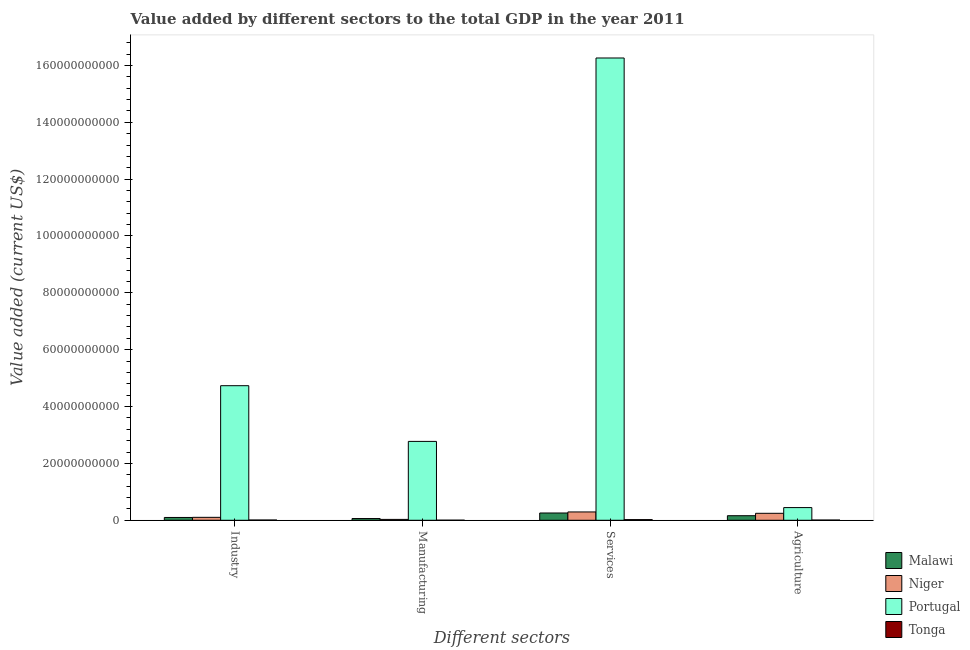Are the number of bars per tick equal to the number of legend labels?
Your answer should be very brief. Yes. How many bars are there on the 3rd tick from the left?
Your answer should be compact. 4. How many bars are there on the 1st tick from the right?
Provide a short and direct response. 4. What is the label of the 2nd group of bars from the left?
Provide a short and direct response. Manufacturing. What is the value added by services sector in Malawi?
Offer a very short reply. 2.56e+09. Across all countries, what is the maximum value added by agricultural sector?
Your answer should be very brief. 4.46e+09. Across all countries, what is the minimum value added by services sector?
Provide a short and direct response. 2.27e+08. In which country was the value added by industrial sector maximum?
Your response must be concise. Portugal. In which country was the value added by services sector minimum?
Offer a terse response. Tonga. What is the total value added by industrial sector in the graph?
Provide a succinct answer. 4.94e+1. What is the difference between the value added by manufacturing sector in Tonga and that in Malawi?
Offer a terse response. -5.83e+08. What is the difference between the value added by services sector in Niger and the value added by industrial sector in Portugal?
Keep it short and to the point. -4.44e+1. What is the average value added by agricultural sector per country?
Your answer should be very brief. 2.15e+09. What is the difference between the value added by manufacturing sector and value added by agricultural sector in Portugal?
Your answer should be very brief. 2.33e+1. What is the ratio of the value added by services sector in Tonga to that in Niger?
Your answer should be compact. 0.08. Is the value added by industrial sector in Niger less than that in Tonga?
Keep it short and to the point. No. What is the difference between the highest and the second highest value added by services sector?
Ensure brevity in your answer.  1.60e+11. What is the difference between the highest and the lowest value added by industrial sector?
Ensure brevity in your answer.  4.72e+1. In how many countries, is the value added by agricultural sector greater than the average value added by agricultural sector taken over all countries?
Your answer should be very brief. 2. What does the 2nd bar from the left in Manufacturing represents?
Keep it short and to the point. Niger. What does the 1st bar from the right in Services represents?
Give a very brief answer. Tonga. How many countries are there in the graph?
Make the answer very short. 4. What is the difference between two consecutive major ticks on the Y-axis?
Your answer should be compact. 2.00e+1. Are the values on the major ticks of Y-axis written in scientific E-notation?
Your answer should be compact. No. Does the graph contain any zero values?
Offer a very short reply. No. Does the graph contain grids?
Offer a very short reply. No. Where does the legend appear in the graph?
Your response must be concise. Bottom right. How many legend labels are there?
Offer a very short reply. 4. How are the legend labels stacked?
Keep it short and to the point. Vertical. What is the title of the graph?
Offer a terse response. Value added by different sectors to the total GDP in the year 2011. What is the label or title of the X-axis?
Offer a terse response. Different sectors. What is the label or title of the Y-axis?
Offer a terse response. Value added (current US$). What is the Value added (current US$) in Malawi in Industry?
Make the answer very short. 9.87e+08. What is the Value added (current US$) in Niger in Industry?
Your answer should be very brief. 1.03e+09. What is the Value added (current US$) in Portugal in Industry?
Provide a succinct answer. 4.73e+1. What is the Value added (current US$) of Tonga in Industry?
Ensure brevity in your answer.  8.54e+07. What is the Value added (current US$) in Malawi in Manufacturing?
Ensure brevity in your answer.  6.09e+08. What is the Value added (current US$) of Niger in Manufacturing?
Provide a succinct answer. 3.05e+08. What is the Value added (current US$) of Portugal in Manufacturing?
Provide a short and direct response. 2.77e+1. What is the Value added (current US$) of Tonga in Manufacturing?
Your response must be concise. 2.65e+07. What is the Value added (current US$) of Malawi in Services?
Keep it short and to the point. 2.56e+09. What is the Value added (current US$) in Niger in Services?
Offer a terse response. 2.93e+09. What is the Value added (current US$) in Portugal in Services?
Make the answer very short. 1.63e+11. What is the Value added (current US$) of Tonga in Services?
Provide a succinct answer. 2.27e+08. What is the Value added (current US$) of Malawi in Agriculture?
Keep it short and to the point. 1.60e+09. What is the Value added (current US$) in Niger in Agriculture?
Provide a short and direct response. 2.45e+09. What is the Value added (current US$) of Portugal in Agriculture?
Your answer should be compact. 4.46e+09. What is the Value added (current US$) of Tonga in Agriculture?
Offer a very short reply. 7.64e+07. Across all Different sectors, what is the maximum Value added (current US$) of Malawi?
Your response must be concise. 2.56e+09. Across all Different sectors, what is the maximum Value added (current US$) of Niger?
Your answer should be compact. 2.93e+09. Across all Different sectors, what is the maximum Value added (current US$) in Portugal?
Make the answer very short. 1.63e+11. Across all Different sectors, what is the maximum Value added (current US$) in Tonga?
Offer a very short reply. 2.27e+08. Across all Different sectors, what is the minimum Value added (current US$) in Malawi?
Give a very brief answer. 6.09e+08. Across all Different sectors, what is the minimum Value added (current US$) in Niger?
Make the answer very short. 3.05e+08. Across all Different sectors, what is the minimum Value added (current US$) of Portugal?
Your answer should be very brief. 4.46e+09. Across all Different sectors, what is the minimum Value added (current US$) in Tonga?
Provide a short and direct response. 2.65e+07. What is the total Value added (current US$) in Malawi in the graph?
Your answer should be very brief. 5.76e+09. What is the total Value added (current US$) of Niger in the graph?
Your response must be concise. 6.71e+09. What is the total Value added (current US$) of Portugal in the graph?
Provide a succinct answer. 2.42e+11. What is the total Value added (current US$) of Tonga in the graph?
Give a very brief answer. 4.15e+08. What is the difference between the Value added (current US$) of Malawi in Industry and that in Manufacturing?
Ensure brevity in your answer.  3.77e+08. What is the difference between the Value added (current US$) of Niger in Industry and that in Manufacturing?
Ensure brevity in your answer.  7.26e+08. What is the difference between the Value added (current US$) of Portugal in Industry and that in Manufacturing?
Offer a terse response. 1.96e+1. What is the difference between the Value added (current US$) in Tonga in Industry and that in Manufacturing?
Offer a terse response. 5.89e+07. What is the difference between the Value added (current US$) in Malawi in Industry and that in Services?
Ensure brevity in your answer.  -1.57e+09. What is the difference between the Value added (current US$) of Niger in Industry and that in Services?
Provide a succinct answer. -1.89e+09. What is the difference between the Value added (current US$) in Portugal in Industry and that in Services?
Offer a very short reply. -1.15e+11. What is the difference between the Value added (current US$) of Tonga in Industry and that in Services?
Keep it short and to the point. -1.41e+08. What is the difference between the Value added (current US$) of Malawi in Industry and that in Agriculture?
Provide a succinct answer. -6.17e+08. What is the difference between the Value added (current US$) in Niger in Industry and that in Agriculture?
Make the answer very short. -1.42e+09. What is the difference between the Value added (current US$) of Portugal in Industry and that in Agriculture?
Your answer should be compact. 4.29e+1. What is the difference between the Value added (current US$) in Tonga in Industry and that in Agriculture?
Provide a short and direct response. 9.06e+06. What is the difference between the Value added (current US$) in Malawi in Manufacturing and that in Services?
Offer a terse response. -1.95e+09. What is the difference between the Value added (current US$) of Niger in Manufacturing and that in Services?
Make the answer very short. -2.62e+09. What is the difference between the Value added (current US$) in Portugal in Manufacturing and that in Services?
Ensure brevity in your answer.  -1.35e+11. What is the difference between the Value added (current US$) in Tonga in Manufacturing and that in Services?
Your answer should be compact. -2.00e+08. What is the difference between the Value added (current US$) of Malawi in Manufacturing and that in Agriculture?
Offer a terse response. -9.94e+08. What is the difference between the Value added (current US$) of Niger in Manufacturing and that in Agriculture?
Give a very brief answer. -2.15e+09. What is the difference between the Value added (current US$) of Portugal in Manufacturing and that in Agriculture?
Offer a terse response. 2.33e+1. What is the difference between the Value added (current US$) in Tonga in Manufacturing and that in Agriculture?
Keep it short and to the point. -4.98e+07. What is the difference between the Value added (current US$) in Malawi in Services and that in Agriculture?
Keep it short and to the point. 9.57e+08. What is the difference between the Value added (current US$) of Niger in Services and that in Agriculture?
Keep it short and to the point. 4.75e+08. What is the difference between the Value added (current US$) in Portugal in Services and that in Agriculture?
Offer a terse response. 1.58e+11. What is the difference between the Value added (current US$) in Tonga in Services and that in Agriculture?
Give a very brief answer. 1.50e+08. What is the difference between the Value added (current US$) of Malawi in Industry and the Value added (current US$) of Niger in Manufacturing?
Offer a terse response. 6.82e+08. What is the difference between the Value added (current US$) of Malawi in Industry and the Value added (current US$) of Portugal in Manufacturing?
Ensure brevity in your answer.  -2.68e+1. What is the difference between the Value added (current US$) in Malawi in Industry and the Value added (current US$) in Tonga in Manufacturing?
Provide a short and direct response. 9.60e+08. What is the difference between the Value added (current US$) in Niger in Industry and the Value added (current US$) in Portugal in Manufacturing?
Ensure brevity in your answer.  -2.67e+1. What is the difference between the Value added (current US$) of Niger in Industry and the Value added (current US$) of Tonga in Manufacturing?
Give a very brief answer. 1.00e+09. What is the difference between the Value added (current US$) of Portugal in Industry and the Value added (current US$) of Tonga in Manufacturing?
Offer a very short reply. 4.73e+1. What is the difference between the Value added (current US$) of Malawi in Industry and the Value added (current US$) of Niger in Services?
Keep it short and to the point. -1.94e+09. What is the difference between the Value added (current US$) of Malawi in Industry and the Value added (current US$) of Portugal in Services?
Make the answer very short. -1.62e+11. What is the difference between the Value added (current US$) of Malawi in Industry and the Value added (current US$) of Tonga in Services?
Ensure brevity in your answer.  7.60e+08. What is the difference between the Value added (current US$) in Niger in Industry and the Value added (current US$) in Portugal in Services?
Keep it short and to the point. -1.62e+11. What is the difference between the Value added (current US$) in Niger in Industry and the Value added (current US$) in Tonga in Services?
Keep it short and to the point. 8.05e+08. What is the difference between the Value added (current US$) of Portugal in Industry and the Value added (current US$) of Tonga in Services?
Offer a terse response. 4.71e+1. What is the difference between the Value added (current US$) of Malawi in Industry and the Value added (current US$) of Niger in Agriculture?
Give a very brief answer. -1.46e+09. What is the difference between the Value added (current US$) in Malawi in Industry and the Value added (current US$) in Portugal in Agriculture?
Your answer should be compact. -3.47e+09. What is the difference between the Value added (current US$) of Malawi in Industry and the Value added (current US$) of Tonga in Agriculture?
Your answer should be very brief. 9.11e+08. What is the difference between the Value added (current US$) in Niger in Industry and the Value added (current US$) in Portugal in Agriculture?
Your answer should be compact. -3.43e+09. What is the difference between the Value added (current US$) of Niger in Industry and the Value added (current US$) of Tonga in Agriculture?
Keep it short and to the point. 9.55e+08. What is the difference between the Value added (current US$) of Portugal in Industry and the Value added (current US$) of Tonga in Agriculture?
Offer a terse response. 4.73e+1. What is the difference between the Value added (current US$) of Malawi in Manufacturing and the Value added (current US$) of Niger in Services?
Give a very brief answer. -2.32e+09. What is the difference between the Value added (current US$) in Malawi in Manufacturing and the Value added (current US$) in Portugal in Services?
Your answer should be very brief. -1.62e+11. What is the difference between the Value added (current US$) of Malawi in Manufacturing and the Value added (current US$) of Tonga in Services?
Offer a terse response. 3.83e+08. What is the difference between the Value added (current US$) of Niger in Manufacturing and the Value added (current US$) of Portugal in Services?
Give a very brief answer. -1.62e+11. What is the difference between the Value added (current US$) in Niger in Manufacturing and the Value added (current US$) in Tonga in Services?
Offer a very short reply. 7.85e+07. What is the difference between the Value added (current US$) in Portugal in Manufacturing and the Value added (current US$) in Tonga in Services?
Offer a very short reply. 2.75e+1. What is the difference between the Value added (current US$) of Malawi in Manufacturing and the Value added (current US$) of Niger in Agriculture?
Ensure brevity in your answer.  -1.84e+09. What is the difference between the Value added (current US$) of Malawi in Manufacturing and the Value added (current US$) of Portugal in Agriculture?
Give a very brief answer. -3.85e+09. What is the difference between the Value added (current US$) in Malawi in Manufacturing and the Value added (current US$) in Tonga in Agriculture?
Your response must be concise. 5.33e+08. What is the difference between the Value added (current US$) of Niger in Manufacturing and the Value added (current US$) of Portugal in Agriculture?
Ensure brevity in your answer.  -4.16e+09. What is the difference between the Value added (current US$) in Niger in Manufacturing and the Value added (current US$) in Tonga in Agriculture?
Provide a short and direct response. 2.29e+08. What is the difference between the Value added (current US$) of Portugal in Manufacturing and the Value added (current US$) of Tonga in Agriculture?
Your answer should be compact. 2.77e+1. What is the difference between the Value added (current US$) in Malawi in Services and the Value added (current US$) in Niger in Agriculture?
Keep it short and to the point. 1.09e+08. What is the difference between the Value added (current US$) of Malawi in Services and the Value added (current US$) of Portugal in Agriculture?
Provide a short and direct response. -1.90e+09. What is the difference between the Value added (current US$) in Malawi in Services and the Value added (current US$) in Tonga in Agriculture?
Offer a terse response. 2.48e+09. What is the difference between the Value added (current US$) of Niger in Services and the Value added (current US$) of Portugal in Agriculture?
Your answer should be compact. -1.53e+09. What is the difference between the Value added (current US$) of Niger in Services and the Value added (current US$) of Tonga in Agriculture?
Provide a short and direct response. 2.85e+09. What is the difference between the Value added (current US$) in Portugal in Services and the Value added (current US$) in Tonga in Agriculture?
Ensure brevity in your answer.  1.63e+11. What is the average Value added (current US$) of Malawi per Different sectors?
Your response must be concise. 1.44e+09. What is the average Value added (current US$) in Niger per Different sectors?
Provide a short and direct response. 1.68e+09. What is the average Value added (current US$) in Portugal per Different sectors?
Make the answer very short. 6.05e+1. What is the average Value added (current US$) in Tonga per Different sectors?
Ensure brevity in your answer.  1.04e+08. What is the difference between the Value added (current US$) in Malawi and Value added (current US$) in Niger in Industry?
Keep it short and to the point. -4.44e+07. What is the difference between the Value added (current US$) in Malawi and Value added (current US$) in Portugal in Industry?
Give a very brief answer. -4.63e+1. What is the difference between the Value added (current US$) of Malawi and Value added (current US$) of Tonga in Industry?
Offer a very short reply. 9.02e+08. What is the difference between the Value added (current US$) of Niger and Value added (current US$) of Portugal in Industry?
Provide a succinct answer. -4.63e+1. What is the difference between the Value added (current US$) of Niger and Value added (current US$) of Tonga in Industry?
Keep it short and to the point. 9.46e+08. What is the difference between the Value added (current US$) in Portugal and Value added (current US$) in Tonga in Industry?
Offer a terse response. 4.72e+1. What is the difference between the Value added (current US$) of Malawi and Value added (current US$) of Niger in Manufacturing?
Offer a very short reply. 3.04e+08. What is the difference between the Value added (current US$) in Malawi and Value added (current US$) in Portugal in Manufacturing?
Give a very brief answer. -2.71e+1. What is the difference between the Value added (current US$) of Malawi and Value added (current US$) of Tonga in Manufacturing?
Keep it short and to the point. 5.83e+08. What is the difference between the Value added (current US$) in Niger and Value added (current US$) in Portugal in Manufacturing?
Offer a terse response. -2.74e+1. What is the difference between the Value added (current US$) in Niger and Value added (current US$) in Tonga in Manufacturing?
Make the answer very short. 2.78e+08. What is the difference between the Value added (current US$) of Portugal and Value added (current US$) of Tonga in Manufacturing?
Your answer should be compact. 2.77e+1. What is the difference between the Value added (current US$) in Malawi and Value added (current US$) in Niger in Services?
Make the answer very short. -3.66e+08. What is the difference between the Value added (current US$) of Malawi and Value added (current US$) of Portugal in Services?
Provide a short and direct response. -1.60e+11. What is the difference between the Value added (current US$) of Malawi and Value added (current US$) of Tonga in Services?
Give a very brief answer. 2.33e+09. What is the difference between the Value added (current US$) of Niger and Value added (current US$) of Portugal in Services?
Provide a short and direct response. -1.60e+11. What is the difference between the Value added (current US$) in Niger and Value added (current US$) in Tonga in Services?
Provide a succinct answer. 2.70e+09. What is the difference between the Value added (current US$) of Portugal and Value added (current US$) of Tonga in Services?
Your answer should be compact. 1.62e+11. What is the difference between the Value added (current US$) in Malawi and Value added (current US$) in Niger in Agriculture?
Offer a very short reply. -8.48e+08. What is the difference between the Value added (current US$) of Malawi and Value added (current US$) of Portugal in Agriculture?
Make the answer very short. -2.86e+09. What is the difference between the Value added (current US$) in Malawi and Value added (current US$) in Tonga in Agriculture?
Ensure brevity in your answer.  1.53e+09. What is the difference between the Value added (current US$) in Niger and Value added (current US$) in Portugal in Agriculture?
Provide a succinct answer. -2.01e+09. What is the difference between the Value added (current US$) in Niger and Value added (current US$) in Tonga in Agriculture?
Offer a terse response. 2.38e+09. What is the difference between the Value added (current US$) in Portugal and Value added (current US$) in Tonga in Agriculture?
Your response must be concise. 4.38e+09. What is the ratio of the Value added (current US$) in Malawi in Industry to that in Manufacturing?
Offer a terse response. 1.62. What is the ratio of the Value added (current US$) in Niger in Industry to that in Manufacturing?
Your answer should be very brief. 3.38. What is the ratio of the Value added (current US$) in Portugal in Industry to that in Manufacturing?
Keep it short and to the point. 1.71. What is the ratio of the Value added (current US$) of Tonga in Industry to that in Manufacturing?
Provide a succinct answer. 3.22. What is the ratio of the Value added (current US$) in Malawi in Industry to that in Services?
Your answer should be compact. 0.39. What is the ratio of the Value added (current US$) in Niger in Industry to that in Services?
Your answer should be very brief. 0.35. What is the ratio of the Value added (current US$) of Portugal in Industry to that in Services?
Give a very brief answer. 0.29. What is the ratio of the Value added (current US$) of Tonga in Industry to that in Services?
Make the answer very short. 0.38. What is the ratio of the Value added (current US$) in Malawi in Industry to that in Agriculture?
Give a very brief answer. 0.62. What is the ratio of the Value added (current US$) of Niger in Industry to that in Agriculture?
Give a very brief answer. 0.42. What is the ratio of the Value added (current US$) in Portugal in Industry to that in Agriculture?
Your answer should be very brief. 10.61. What is the ratio of the Value added (current US$) in Tonga in Industry to that in Agriculture?
Offer a very short reply. 1.12. What is the ratio of the Value added (current US$) in Malawi in Manufacturing to that in Services?
Offer a very short reply. 0.24. What is the ratio of the Value added (current US$) of Niger in Manufacturing to that in Services?
Your answer should be compact. 0.1. What is the ratio of the Value added (current US$) in Portugal in Manufacturing to that in Services?
Provide a short and direct response. 0.17. What is the ratio of the Value added (current US$) of Tonga in Manufacturing to that in Services?
Your answer should be very brief. 0.12. What is the ratio of the Value added (current US$) in Malawi in Manufacturing to that in Agriculture?
Your response must be concise. 0.38. What is the ratio of the Value added (current US$) in Niger in Manufacturing to that in Agriculture?
Keep it short and to the point. 0.12. What is the ratio of the Value added (current US$) in Portugal in Manufacturing to that in Agriculture?
Ensure brevity in your answer.  6.22. What is the ratio of the Value added (current US$) of Tonga in Manufacturing to that in Agriculture?
Your answer should be very brief. 0.35. What is the ratio of the Value added (current US$) in Malawi in Services to that in Agriculture?
Your response must be concise. 1.6. What is the ratio of the Value added (current US$) in Niger in Services to that in Agriculture?
Offer a terse response. 1.19. What is the ratio of the Value added (current US$) of Portugal in Services to that in Agriculture?
Your answer should be very brief. 36.46. What is the ratio of the Value added (current US$) in Tonga in Services to that in Agriculture?
Ensure brevity in your answer.  2.97. What is the difference between the highest and the second highest Value added (current US$) in Malawi?
Provide a succinct answer. 9.57e+08. What is the difference between the highest and the second highest Value added (current US$) of Niger?
Give a very brief answer. 4.75e+08. What is the difference between the highest and the second highest Value added (current US$) of Portugal?
Ensure brevity in your answer.  1.15e+11. What is the difference between the highest and the second highest Value added (current US$) of Tonga?
Provide a short and direct response. 1.41e+08. What is the difference between the highest and the lowest Value added (current US$) of Malawi?
Your answer should be compact. 1.95e+09. What is the difference between the highest and the lowest Value added (current US$) of Niger?
Make the answer very short. 2.62e+09. What is the difference between the highest and the lowest Value added (current US$) in Portugal?
Offer a terse response. 1.58e+11. What is the difference between the highest and the lowest Value added (current US$) of Tonga?
Offer a terse response. 2.00e+08. 